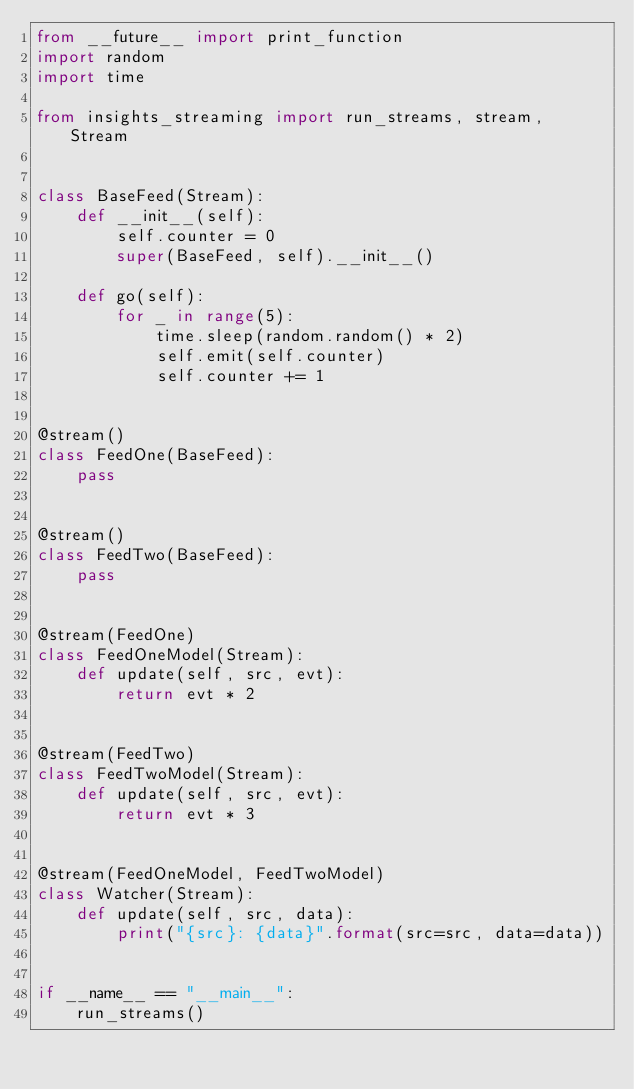<code> <loc_0><loc_0><loc_500><loc_500><_Python_>from __future__ import print_function
import random
import time

from insights_streaming import run_streams, stream, Stream


class BaseFeed(Stream):
    def __init__(self):
        self.counter = 0
        super(BaseFeed, self).__init__()

    def go(self):
        for _ in range(5):
            time.sleep(random.random() * 2)
            self.emit(self.counter)
            self.counter += 1


@stream()
class FeedOne(BaseFeed):
    pass


@stream()
class FeedTwo(BaseFeed):
    pass


@stream(FeedOne)
class FeedOneModel(Stream):
    def update(self, src, evt):
        return evt * 2


@stream(FeedTwo)
class FeedTwoModel(Stream):
    def update(self, src, evt):
        return evt * 3


@stream(FeedOneModel, FeedTwoModel)
class Watcher(Stream):
    def update(self, src, data):
        print("{src}: {data}".format(src=src, data=data))


if __name__ == "__main__":
    run_streams()
</code> 